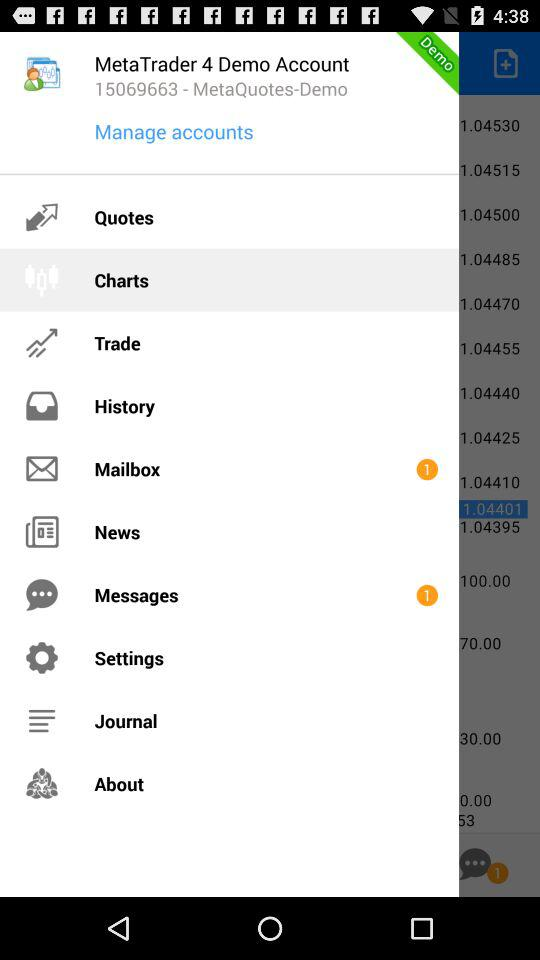How many unread messages are there? There is 1 unread message. 